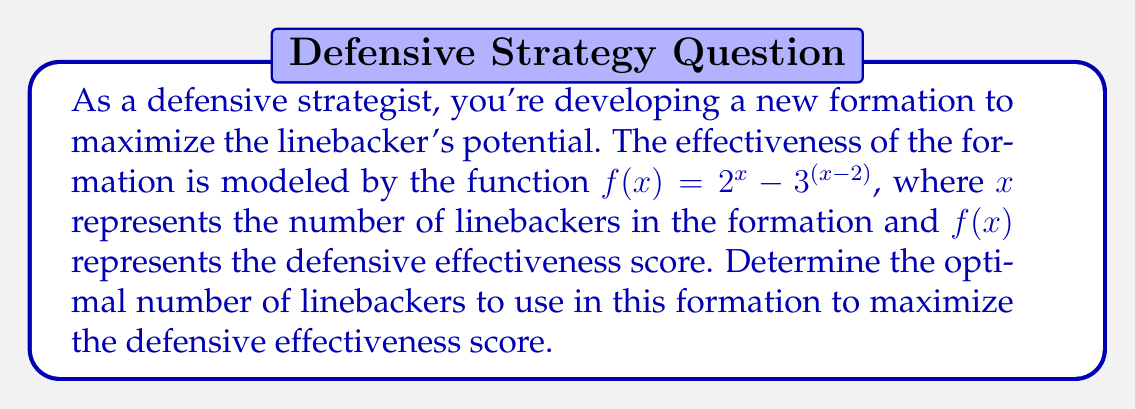Solve this math problem. To find the optimal number of linebackers, we need to determine the maximum value of the function $f(x) = 2^x - 3^{(x-2)}$. We can do this by following these steps:

1) First, let's calculate $f(x)$ for a few integer values of $x$ to get an idea of the function's behavior:

   For $x = 1$: $f(1) = 2^1 - 3^{(1-2)} = 2 - 3^{-1} = 2 - \frac{1}{3} = 1.67$
   For $x = 2$: $f(2) = 2^2 - 3^{(2-2)} = 4 - 3^0 = 4 - 1 = 3$
   For $x = 3$: $f(3) = 2^3 - 3^{(3-2)} = 8 - 3^1 = 8 - 3 = 5$
   For $x = 4$: $f(4) = 2^4 - 3^{(4-2)} = 16 - 3^2 = 16 - 9 = 7$
   For $x = 5$: $f(5) = 2^5 - 3^{(5-2)} = 32 - 3^3 = 32 - 27 = 5$

2) We can see that the function increases up to $x = 4$ and then starts decreasing.

3) To confirm this is the maximum, we can check the values on either side of $x = 4$:

   $f(3) = 5$
   $f(4) = 7$
   $f(5) = 5$

4) Since $f(4)$ is greater than both $f(3)$ and $f(5)$, we can conclude that the maximum occurs at $x = 4$.

Therefore, the optimal number of linebackers to use in this formation is 4, which gives the maximum defensive effectiveness score of 7.
Answer: The optimal number of linebackers is 4, resulting in a maximum defensive effectiveness score of 7. 